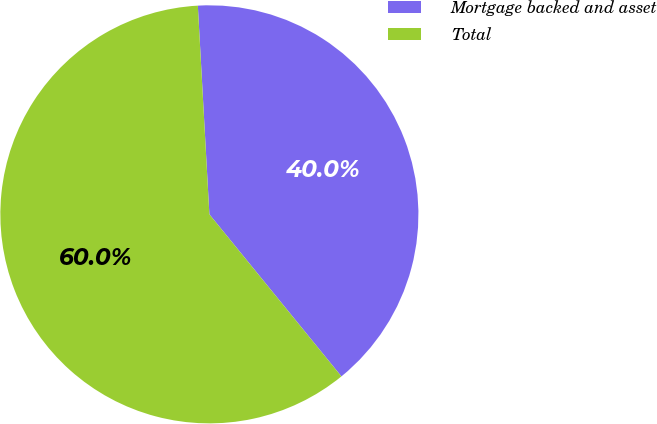Convert chart to OTSL. <chart><loc_0><loc_0><loc_500><loc_500><pie_chart><fcel>Mortgage backed and asset<fcel>Total<nl><fcel>40.0%<fcel>60.0%<nl></chart> 